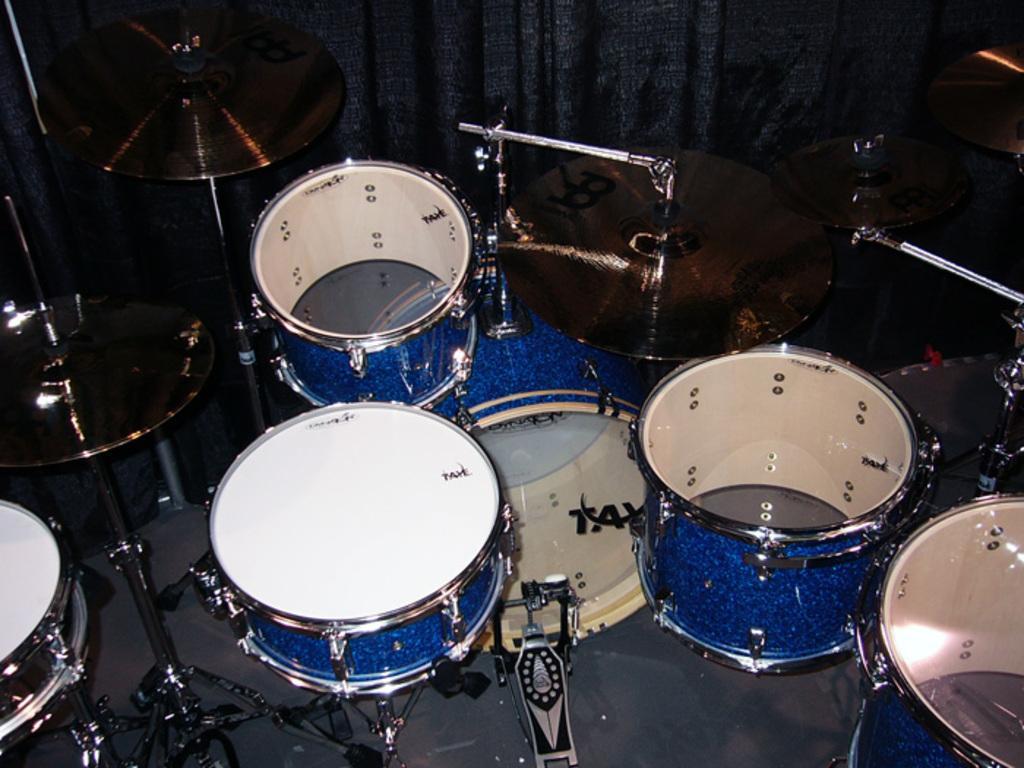Describe this image in one or two sentences. In this image we can see a musical instrument. In the background there is a curtain. 